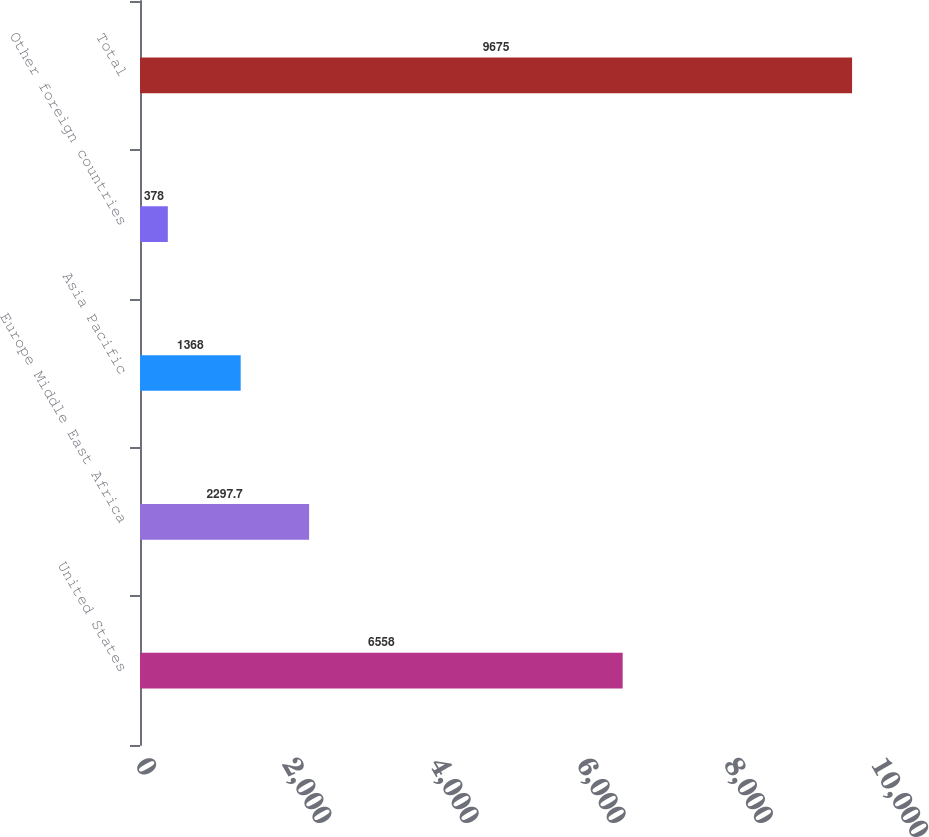Convert chart. <chart><loc_0><loc_0><loc_500><loc_500><bar_chart><fcel>United States<fcel>Europe Middle East Africa<fcel>Asia Pacific<fcel>Other foreign countries<fcel>Total<nl><fcel>6558<fcel>2297.7<fcel>1368<fcel>378<fcel>9675<nl></chart> 